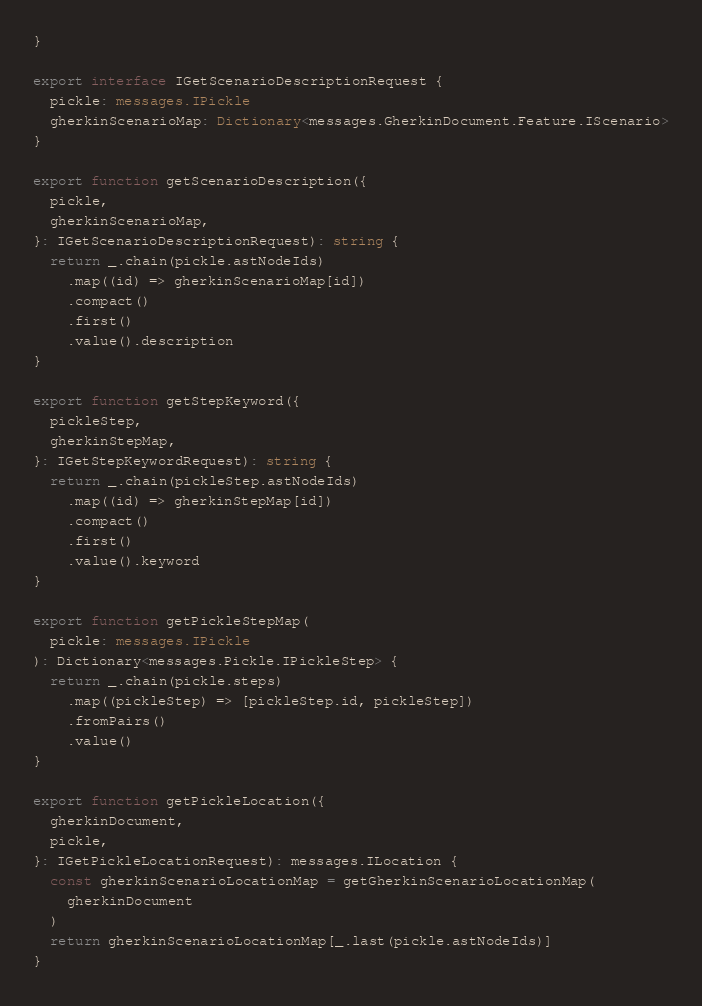<code> <loc_0><loc_0><loc_500><loc_500><_TypeScript_>}

export interface IGetScenarioDescriptionRequest {
  pickle: messages.IPickle
  gherkinScenarioMap: Dictionary<messages.GherkinDocument.Feature.IScenario>
}

export function getScenarioDescription({
  pickle,
  gherkinScenarioMap,
}: IGetScenarioDescriptionRequest): string {
  return _.chain(pickle.astNodeIds)
    .map((id) => gherkinScenarioMap[id])
    .compact()
    .first()
    .value().description
}

export function getStepKeyword({
  pickleStep,
  gherkinStepMap,
}: IGetStepKeywordRequest): string {
  return _.chain(pickleStep.astNodeIds)
    .map((id) => gherkinStepMap[id])
    .compact()
    .first()
    .value().keyword
}

export function getPickleStepMap(
  pickle: messages.IPickle
): Dictionary<messages.Pickle.IPickleStep> {
  return _.chain(pickle.steps)
    .map((pickleStep) => [pickleStep.id, pickleStep])
    .fromPairs()
    .value()
}

export function getPickleLocation({
  gherkinDocument,
  pickle,
}: IGetPickleLocationRequest): messages.ILocation {
  const gherkinScenarioLocationMap = getGherkinScenarioLocationMap(
    gherkinDocument
  )
  return gherkinScenarioLocationMap[_.last(pickle.astNodeIds)]
}
</code> 